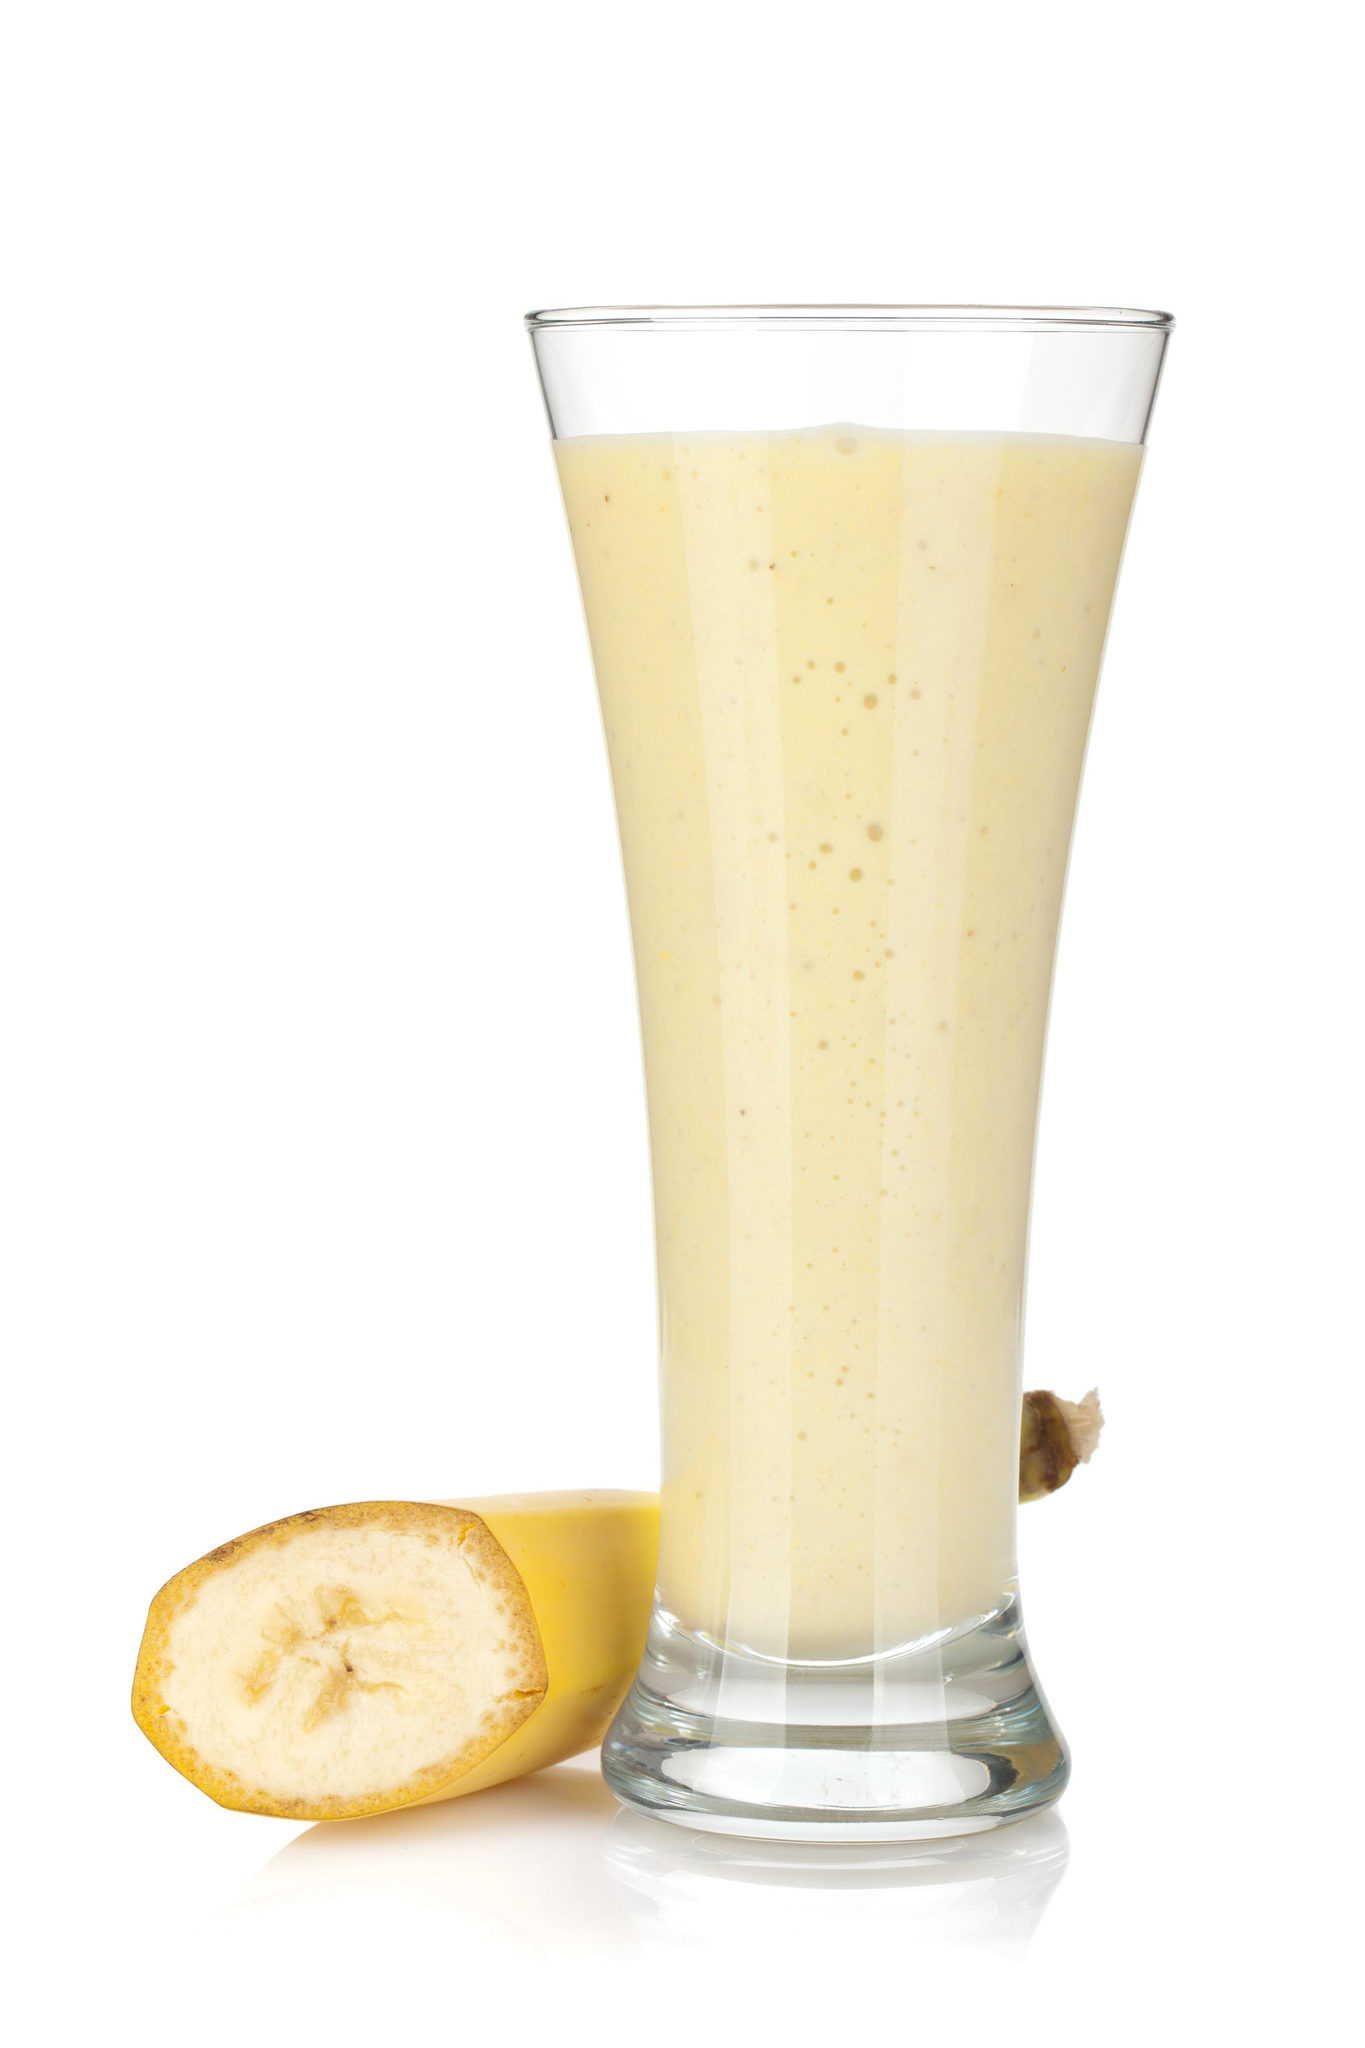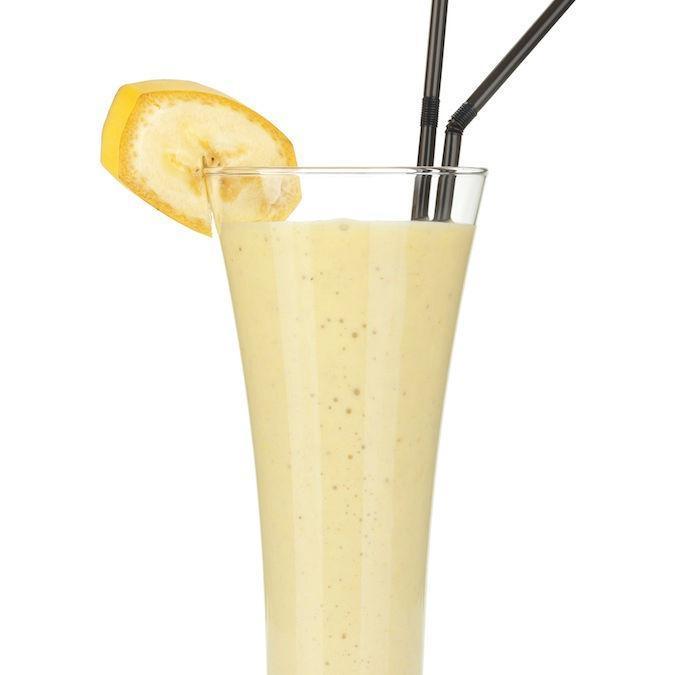The first image is the image on the left, the second image is the image on the right. Considering the images on both sides, is "All the bananas are cut." valid? Answer yes or no. Yes. 